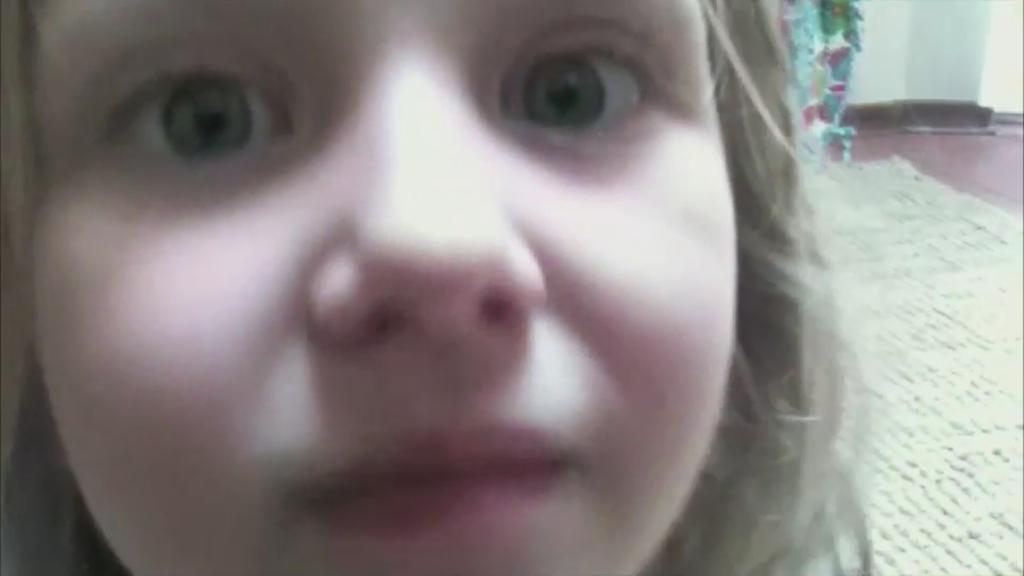Please provide a concise description of this image. In the center of the image we can see a girls face. In the background there is a carpet and wall. 